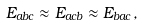<formula> <loc_0><loc_0><loc_500><loc_500>E _ { a b c } \approx E _ { a c b } \approx E _ { b a c } ,</formula> 